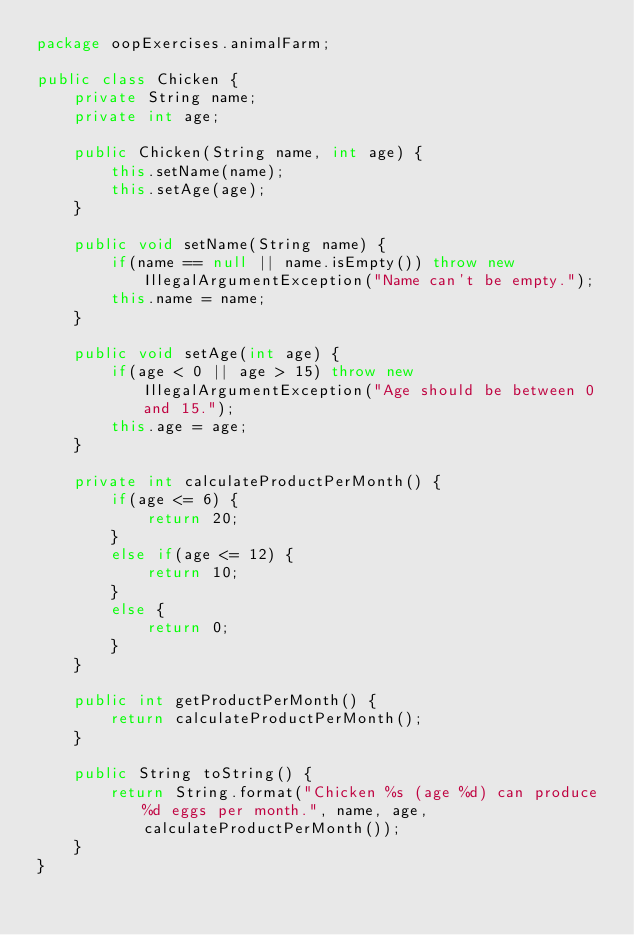<code> <loc_0><loc_0><loc_500><loc_500><_Java_>package oopExercises.animalFarm;

public class Chicken {
    private String name;
    private int age;

    public Chicken(String name, int age) {
        this.setName(name);
        this.setAge(age);
    }

    public void setName(String name) {
        if(name == null || name.isEmpty()) throw new IllegalArgumentException("Name can't be empty.");
        this.name = name;
    }

    public void setAge(int age) {
        if(age < 0 || age > 15) throw new IllegalArgumentException("Age should be between 0 and 15.");
        this.age = age;
    }

    private int calculateProductPerMonth() {
        if(age <= 6) {
            return 20;
        }
        else if(age <= 12) {
            return 10;
        }
        else {
            return 0;
        }
    }

    public int getProductPerMonth() {
        return calculateProductPerMonth();
    }

    public String toString() {
        return String.format("Chicken %s (age %d) can produce %d eggs per month.", name, age, calculateProductPerMonth());
    }
}
</code> 